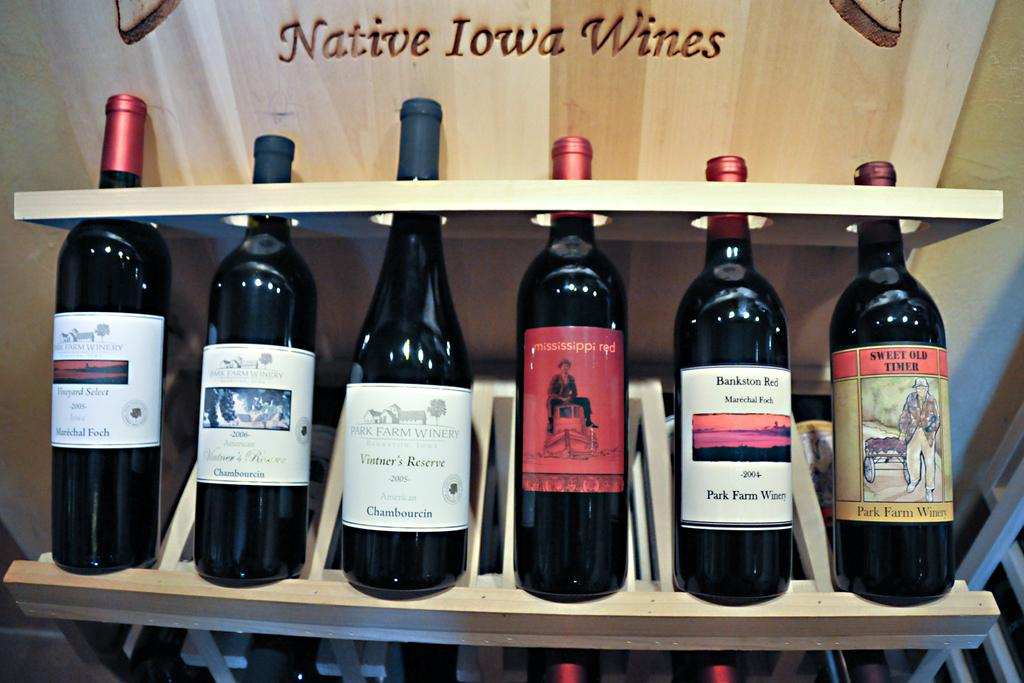<image>
Describe the image concisely. A number of red native Iowa wines on display 